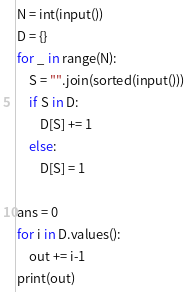Convert code to text. <code><loc_0><loc_0><loc_500><loc_500><_Python_>N = int(input())
D = {}
for _ in range(N):
    S = "".join(sorted(input()))
    if S in D:
        D[S] += 1
    else:
        D[S] = 1
 
ans = 0
for i in D.values():
    out += i-1
print(out)</code> 